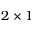<formula> <loc_0><loc_0><loc_500><loc_500>2 \times 1</formula> 